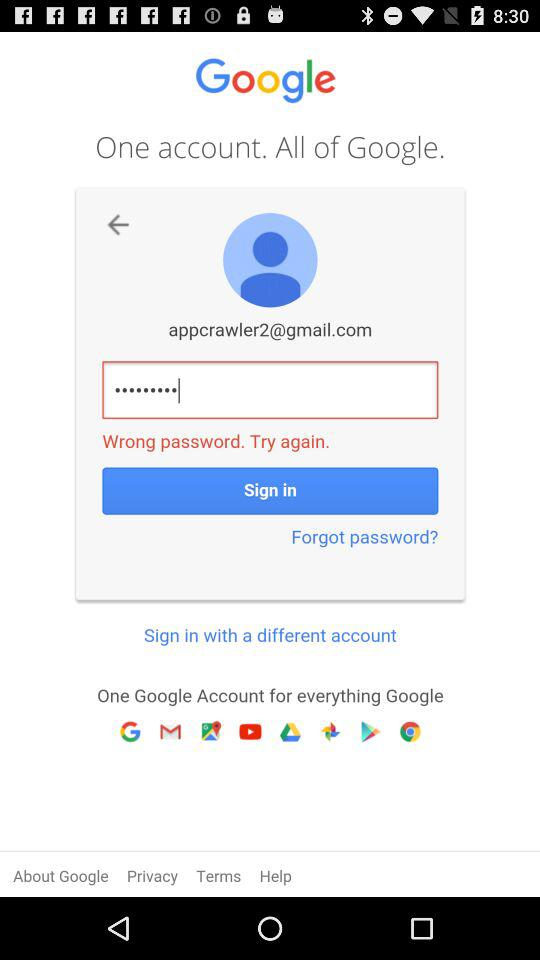Through which different accounts can we sign in?
When the provided information is insufficient, respond with <no answer>. <no answer> 